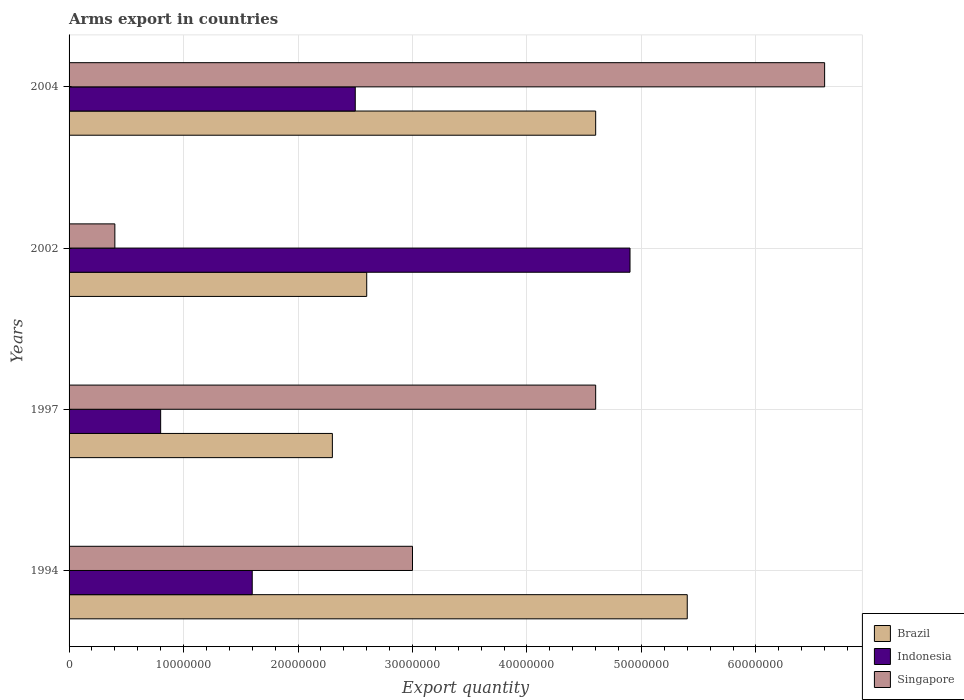How many different coloured bars are there?
Your response must be concise. 3. Are the number of bars per tick equal to the number of legend labels?
Keep it short and to the point. Yes. How many bars are there on the 1st tick from the top?
Offer a very short reply. 3. What is the label of the 3rd group of bars from the top?
Offer a terse response. 1997. In how many cases, is the number of bars for a given year not equal to the number of legend labels?
Provide a succinct answer. 0. What is the total arms export in Singapore in 1994?
Offer a very short reply. 3.00e+07. Across all years, what is the maximum total arms export in Indonesia?
Offer a terse response. 4.90e+07. Across all years, what is the minimum total arms export in Indonesia?
Your answer should be very brief. 8.00e+06. In which year was the total arms export in Singapore maximum?
Your answer should be very brief. 2004. What is the total total arms export in Brazil in the graph?
Offer a very short reply. 1.49e+08. What is the difference between the total arms export in Indonesia in 1997 and that in 2004?
Offer a terse response. -1.70e+07. What is the difference between the total arms export in Indonesia in 1994 and the total arms export in Singapore in 2002?
Your answer should be compact. 1.20e+07. What is the average total arms export in Singapore per year?
Provide a short and direct response. 3.65e+07. In the year 2002, what is the difference between the total arms export in Singapore and total arms export in Brazil?
Offer a terse response. -2.20e+07. What is the ratio of the total arms export in Brazil in 1994 to that in 1997?
Your response must be concise. 2.35. Is the total arms export in Brazil in 1994 less than that in 1997?
Make the answer very short. No. Is the difference between the total arms export in Singapore in 1994 and 2002 greater than the difference between the total arms export in Brazil in 1994 and 2002?
Offer a very short reply. No. What is the difference between the highest and the second highest total arms export in Singapore?
Provide a succinct answer. 2.00e+07. What is the difference between the highest and the lowest total arms export in Singapore?
Your answer should be compact. 6.20e+07. What does the 1st bar from the top in 2002 represents?
Provide a succinct answer. Singapore. Are all the bars in the graph horizontal?
Keep it short and to the point. Yes. What is the difference between two consecutive major ticks on the X-axis?
Give a very brief answer. 1.00e+07. Does the graph contain any zero values?
Your answer should be very brief. No. Does the graph contain grids?
Keep it short and to the point. Yes. Where does the legend appear in the graph?
Offer a very short reply. Bottom right. How many legend labels are there?
Your answer should be very brief. 3. How are the legend labels stacked?
Keep it short and to the point. Vertical. What is the title of the graph?
Keep it short and to the point. Arms export in countries. Does "Congo (Democratic)" appear as one of the legend labels in the graph?
Give a very brief answer. No. What is the label or title of the X-axis?
Keep it short and to the point. Export quantity. What is the Export quantity of Brazil in 1994?
Your response must be concise. 5.40e+07. What is the Export quantity in Indonesia in 1994?
Provide a succinct answer. 1.60e+07. What is the Export quantity in Singapore in 1994?
Provide a succinct answer. 3.00e+07. What is the Export quantity in Brazil in 1997?
Make the answer very short. 2.30e+07. What is the Export quantity in Indonesia in 1997?
Your answer should be compact. 8.00e+06. What is the Export quantity of Singapore in 1997?
Your answer should be compact. 4.60e+07. What is the Export quantity in Brazil in 2002?
Your answer should be very brief. 2.60e+07. What is the Export quantity in Indonesia in 2002?
Provide a succinct answer. 4.90e+07. What is the Export quantity in Brazil in 2004?
Offer a very short reply. 4.60e+07. What is the Export quantity in Indonesia in 2004?
Your response must be concise. 2.50e+07. What is the Export quantity of Singapore in 2004?
Your response must be concise. 6.60e+07. Across all years, what is the maximum Export quantity of Brazil?
Give a very brief answer. 5.40e+07. Across all years, what is the maximum Export quantity in Indonesia?
Offer a very short reply. 4.90e+07. Across all years, what is the maximum Export quantity in Singapore?
Your answer should be very brief. 6.60e+07. Across all years, what is the minimum Export quantity of Brazil?
Ensure brevity in your answer.  2.30e+07. Across all years, what is the minimum Export quantity in Singapore?
Your answer should be very brief. 4.00e+06. What is the total Export quantity of Brazil in the graph?
Your response must be concise. 1.49e+08. What is the total Export quantity of Indonesia in the graph?
Ensure brevity in your answer.  9.80e+07. What is the total Export quantity of Singapore in the graph?
Ensure brevity in your answer.  1.46e+08. What is the difference between the Export quantity of Brazil in 1994 and that in 1997?
Ensure brevity in your answer.  3.10e+07. What is the difference between the Export quantity of Indonesia in 1994 and that in 1997?
Offer a terse response. 8.00e+06. What is the difference between the Export quantity of Singapore in 1994 and that in 1997?
Keep it short and to the point. -1.60e+07. What is the difference between the Export quantity of Brazil in 1994 and that in 2002?
Ensure brevity in your answer.  2.80e+07. What is the difference between the Export quantity in Indonesia in 1994 and that in 2002?
Keep it short and to the point. -3.30e+07. What is the difference between the Export quantity of Singapore in 1994 and that in 2002?
Your response must be concise. 2.60e+07. What is the difference between the Export quantity in Brazil in 1994 and that in 2004?
Offer a terse response. 8.00e+06. What is the difference between the Export quantity of Indonesia in 1994 and that in 2004?
Ensure brevity in your answer.  -9.00e+06. What is the difference between the Export quantity of Singapore in 1994 and that in 2004?
Make the answer very short. -3.60e+07. What is the difference between the Export quantity of Indonesia in 1997 and that in 2002?
Offer a very short reply. -4.10e+07. What is the difference between the Export quantity of Singapore in 1997 and that in 2002?
Give a very brief answer. 4.20e+07. What is the difference between the Export quantity in Brazil in 1997 and that in 2004?
Your response must be concise. -2.30e+07. What is the difference between the Export quantity of Indonesia in 1997 and that in 2004?
Your response must be concise. -1.70e+07. What is the difference between the Export quantity of Singapore in 1997 and that in 2004?
Give a very brief answer. -2.00e+07. What is the difference between the Export quantity of Brazil in 2002 and that in 2004?
Provide a short and direct response. -2.00e+07. What is the difference between the Export quantity of Indonesia in 2002 and that in 2004?
Provide a short and direct response. 2.40e+07. What is the difference between the Export quantity in Singapore in 2002 and that in 2004?
Give a very brief answer. -6.20e+07. What is the difference between the Export quantity in Brazil in 1994 and the Export quantity in Indonesia in 1997?
Offer a very short reply. 4.60e+07. What is the difference between the Export quantity of Indonesia in 1994 and the Export quantity of Singapore in 1997?
Your response must be concise. -3.00e+07. What is the difference between the Export quantity in Brazil in 1994 and the Export quantity in Indonesia in 2002?
Your answer should be very brief. 5.00e+06. What is the difference between the Export quantity in Brazil in 1994 and the Export quantity in Indonesia in 2004?
Provide a succinct answer. 2.90e+07. What is the difference between the Export quantity of Brazil in 1994 and the Export quantity of Singapore in 2004?
Make the answer very short. -1.20e+07. What is the difference between the Export quantity of Indonesia in 1994 and the Export quantity of Singapore in 2004?
Your response must be concise. -5.00e+07. What is the difference between the Export quantity in Brazil in 1997 and the Export quantity in Indonesia in 2002?
Keep it short and to the point. -2.60e+07. What is the difference between the Export quantity in Brazil in 1997 and the Export quantity in Singapore in 2002?
Give a very brief answer. 1.90e+07. What is the difference between the Export quantity of Brazil in 1997 and the Export quantity of Indonesia in 2004?
Provide a short and direct response. -2.00e+06. What is the difference between the Export quantity of Brazil in 1997 and the Export quantity of Singapore in 2004?
Keep it short and to the point. -4.30e+07. What is the difference between the Export quantity of Indonesia in 1997 and the Export quantity of Singapore in 2004?
Make the answer very short. -5.80e+07. What is the difference between the Export quantity in Brazil in 2002 and the Export quantity in Singapore in 2004?
Provide a short and direct response. -4.00e+07. What is the difference between the Export quantity of Indonesia in 2002 and the Export quantity of Singapore in 2004?
Offer a very short reply. -1.70e+07. What is the average Export quantity in Brazil per year?
Your response must be concise. 3.72e+07. What is the average Export quantity in Indonesia per year?
Keep it short and to the point. 2.45e+07. What is the average Export quantity in Singapore per year?
Your answer should be very brief. 3.65e+07. In the year 1994, what is the difference between the Export quantity in Brazil and Export quantity in Indonesia?
Give a very brief answer. 3.80e+07. In the year 1994, what is the difference between the Export quantity of Brazil and Export quantity of Singapore?
Your response must be concise. 2.40e+07. In the year 1994, what is the difference between the Export quantity of Indonesia and Export quantity of Singapore?
Make the answer very short. -1.40e+07. In the year 1997, what is the difference between the Export quantity in Brazil and Export quantity in Indonesia?
Make the answer very short. 1.50e+07. In the year 1997, what is the difference between the Export quantity of Brazil and Export quantity of Singapore?
Your answer should be very brief. -2.30e+07. In the year 1997, what is the difference between the Export quantity of Indonesia and Export quantity of Singapore?
Ensure brevity in your answer.  -3.80e+07. In the year 2002, what is the difference between the Export quantity of Brazil and Export quantity of Indonesia?
Your response must be concise. -2.30e+07. In the year 2002, what is the difference between the Export quantity in Brazil and Export quantity in Singapore?
Provide a succinct answer. 2.20e+07. In the year 2002, what is the difference between the Export quantity in Indonesia and Export quantity in Singapore?
Offer a very short reply. 4.50e+07. In the year 2004, what is the difference between the Export quantity of Brazil and Export quantity of Indonesia?
Give a very brief answer. 2.10e+07. In the year 2004, what is the difference between the Export quantity of Brazil and Export quantity of Singapore?
Provide a short and direct response. -2.00e+07. In the year 2004, what is the difference between the Export quantity of Indonesia and Export quantity of Singapore?
Give a very brief answer. -4.10e+07. What is the ratio of the Export quantity in Brazil in 1994 to that in 1997?
Offer a very short reply. 2.35. What is the ratio of the Export quantity in Singapore in 1994 to that in 1997?
Ensure brevity in your answer.  0.65. What is the ratio of the Export quantity in Brazil in 1994 to that in 2002?
Make the answer very short. 2.08. What is the ratio of the Export quantity of Indonesia in 1994 to that in 2002?
Provide a succinct answer. 0.33. What is the ratio of the Export quantity in Brazil in 1994 to that in 2004?
Your answer should be very brief. 1.17. What is the ratio of the Export quantity in Indonesia in 1994 to that in 2004?
Your answer should be very brief. 0.64. What is the ratio of the Export quantity of Singapore in 1994 to that in 2004?
Give a very brief answer. 0.45. What is the ratio of the Export quantity of Brazil in 1997 to that in 2002?
Provide a succinct answer. 0.88. What is the ratio of the Export quantity of Indonesia in 1997 to that in 2002?
Your answer should be very brief. 0.16. What is the ratio of the Export quantity of Singapore in 1997 to that in 2002?
Your answer should be very brief. 11.5. What is the ratio of the Export quantity in Indonesia in 1997 to that in 2004?
Provide a succinct answer. 0.32. What is the ratio of the Export quantity of Singapore in 1997 to that in 2004?
Offer a terse response. 0.7. What is the ratio of the Export quantity in Brazil in 2002 to that in 2004?
Provide a short and direct response. 0.57. What is the ratio of the Export quantity of Indonesia in 2002 to that in 2004?
Your answer should be compact. 1.96. What is the ratio of the Export quantity in Singapore in 2002 to that in 2004?
Ensure brevity in your answer.  0.06. What is the difference between the highest and the second highest Export quantity in Brazil?
Make the answer very short. 8.00e+06. What is the difference between the highest and the second highest Export quantity in Indonesia?
Give a very brief answer. 2.40e+07. What is the difference between the highest and the second highest Export quantity of Singapore?
Your answer should be compact. 2.00e+07. What is the difference between the highest and the lowest Export quantity of Brazil?
Keep it short and to the point. 3.10e+07. What is the difference between the highest and the lowest Export quantity in Indonesia?
Keep it short and to the point. 4.10e+07. What is the difference between the highest and the lowest Export quantity in Singapore?
Give a very brief answer. 6.20e+07. 